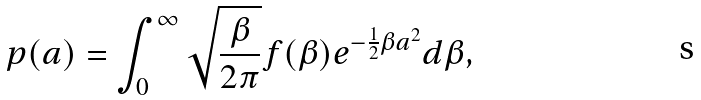<formula> <loc_0><loc_0><loc_500><loc_500>p ( a ) = \int _ { 0 } ^ { \infty } \sqrt { \frac { \beta } { 2 \pi } } f ( \beta ) e ^ { - \frac { 1 } { 2 } \beta a ^ { 2 } } d \beta ,</formula> 